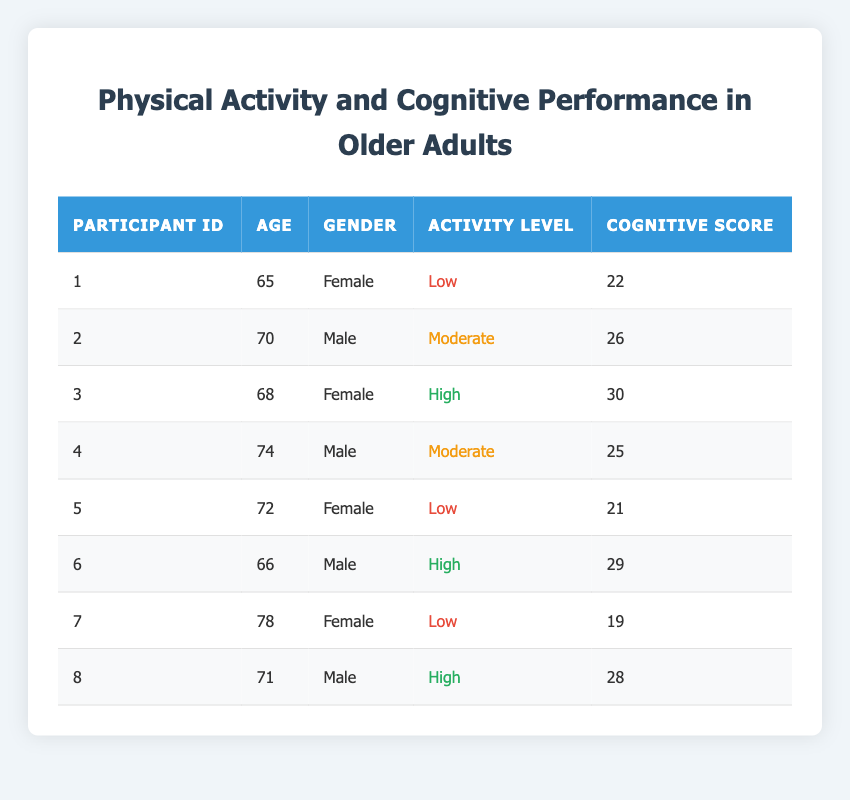What is the cognitive score of participant 3? Participant 3 is located in the third row of the table. The cognitive score listed next to participant 3 is 30.
Answer: 30 How many participants have a high activity level? By reviewing the table, participants 3, 6, and 8 are noted as having a high activity level. Therefore, there are 3 participants in this category.
Answer: 3 What is the average cognitive score of participants with low activity levels? The cognitive scores for participants with low activity levels (participant 1, 5, and 7) are 22, 21, and 19, respectively. Adding these scores gives 22 + 21 + 19 = 62. There are 3 participants, so the average cognitive score is 62/3 = 20.67, which can be rounded to 21 for simplicity.
Answer: 21 Is it true that male participants have higher cognitive scores than female participants? Male participants have cognitive scores of 26, 25, 29, and 28. Summing those gives 108, and the average for males is 108/4 = 27. Female participants have scores of 22, 30, and 19, summing to 71 and an average of 71/3 = 23.67, which means males have a higher average. So, the statement is true.
Answer: Yes What is the median age of participants with a moderate activity level? The participants with a moderate activity level are participants 2 and 4. Their ages are 70 and 74. When arranged in order, the ages are 70 and 74. The median is calculated by finding the average of these two ages: (70 + 74)/2 = 72.
Answer: 72 